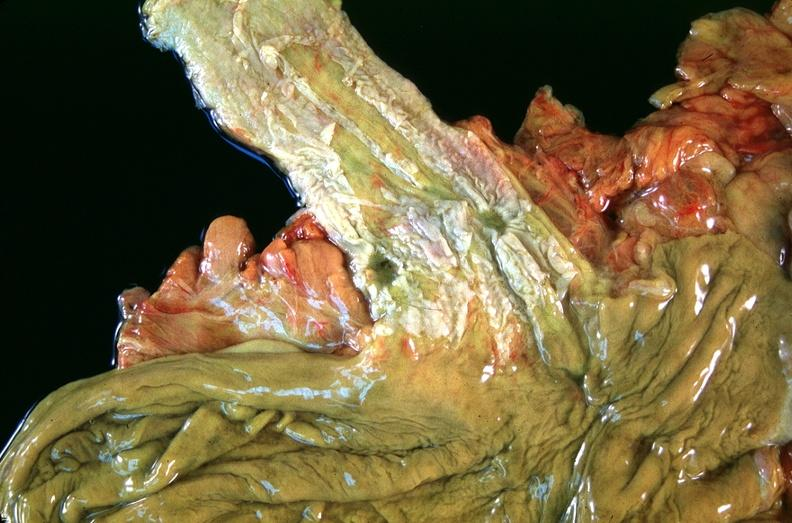s autoimmune thyroiditis present?
Answer the question using a single word or phrase. No 